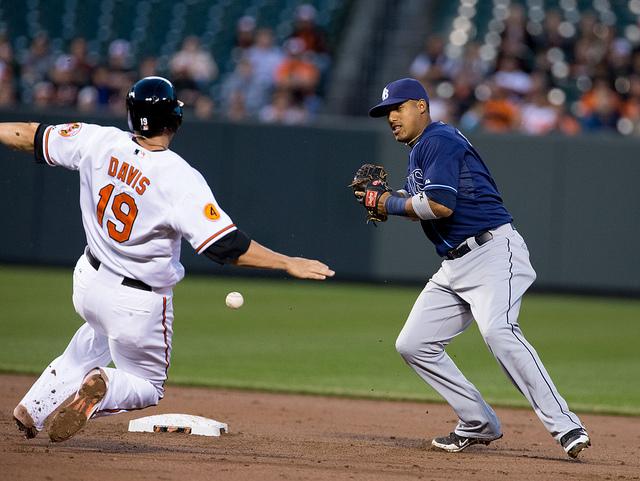Do they play for the same team?
Quick response, please. No. Which base is the running sliding towards?
Quick response, please. 1st. Is one of the players* name Davis?
Concise answer only. Yes. 